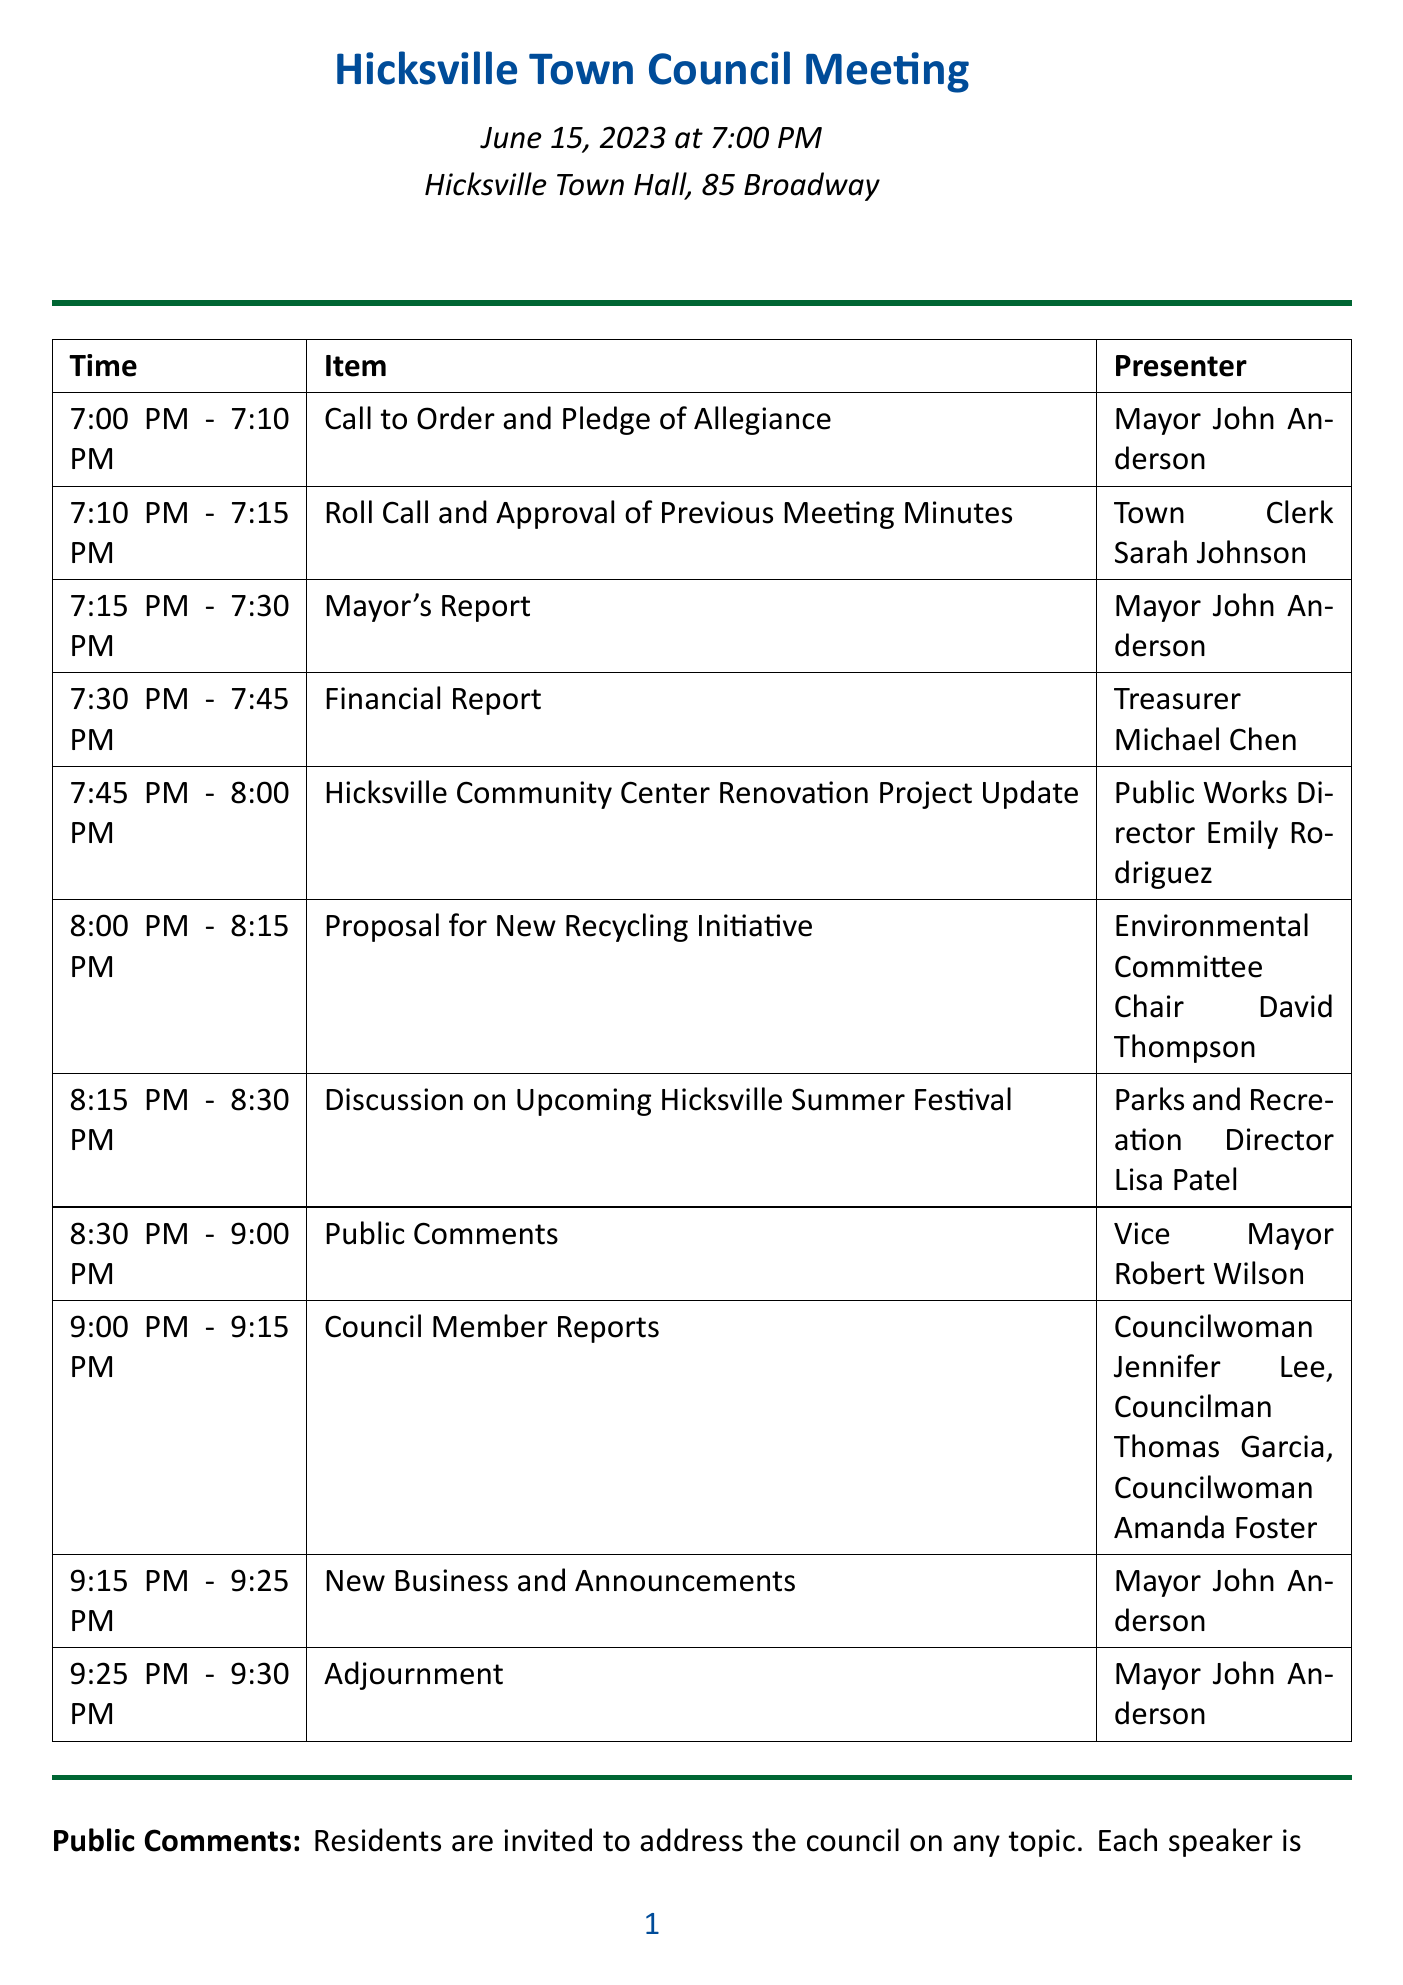What is the date of the meeting? The date of the meeting is specified at the top of the document.
Answer: June 15, 2023 Who presents the Financial Report? The document lists the presenters for each agenda item, including the Financial Report.
Answer: Treasurer Michael Chen What time does Public Comments start? The schedule indicates the time slots for each item, including when Public Comments starts.
Answer: 8:30 PM How long is the Public Comments section? The document specifies the duration of each agenda item, allowing us to calculate the length of Public Comments.
Answer: 30 minutes What is the location of the meeting? The location of the meeting is stated in the introductory section of the document.
Answer: Hicksville Town Hall, 85 Broadway What is the time limit for each speaker during Public Comments? The description under Public Comments clearly outlines the speaking time for residents.
Answer: 3 minutes Who moderates the Public Comments session? The document indicates who will moderate the Public Comments, which is relevant to understanding the structure of that segment.
Answer: Vice Mayor Robert Wilson What is the agenda item immediately following the Mayor's Report? The agenda lays out items in a sequential order, allowing us to identify the one that follows the Mayor's Report.
Answer: Financial Report How many Council Members present their reports? The Council Member Reports section lists the number of individuals presenting during that agenda item.
Answer: 3 Council Members 